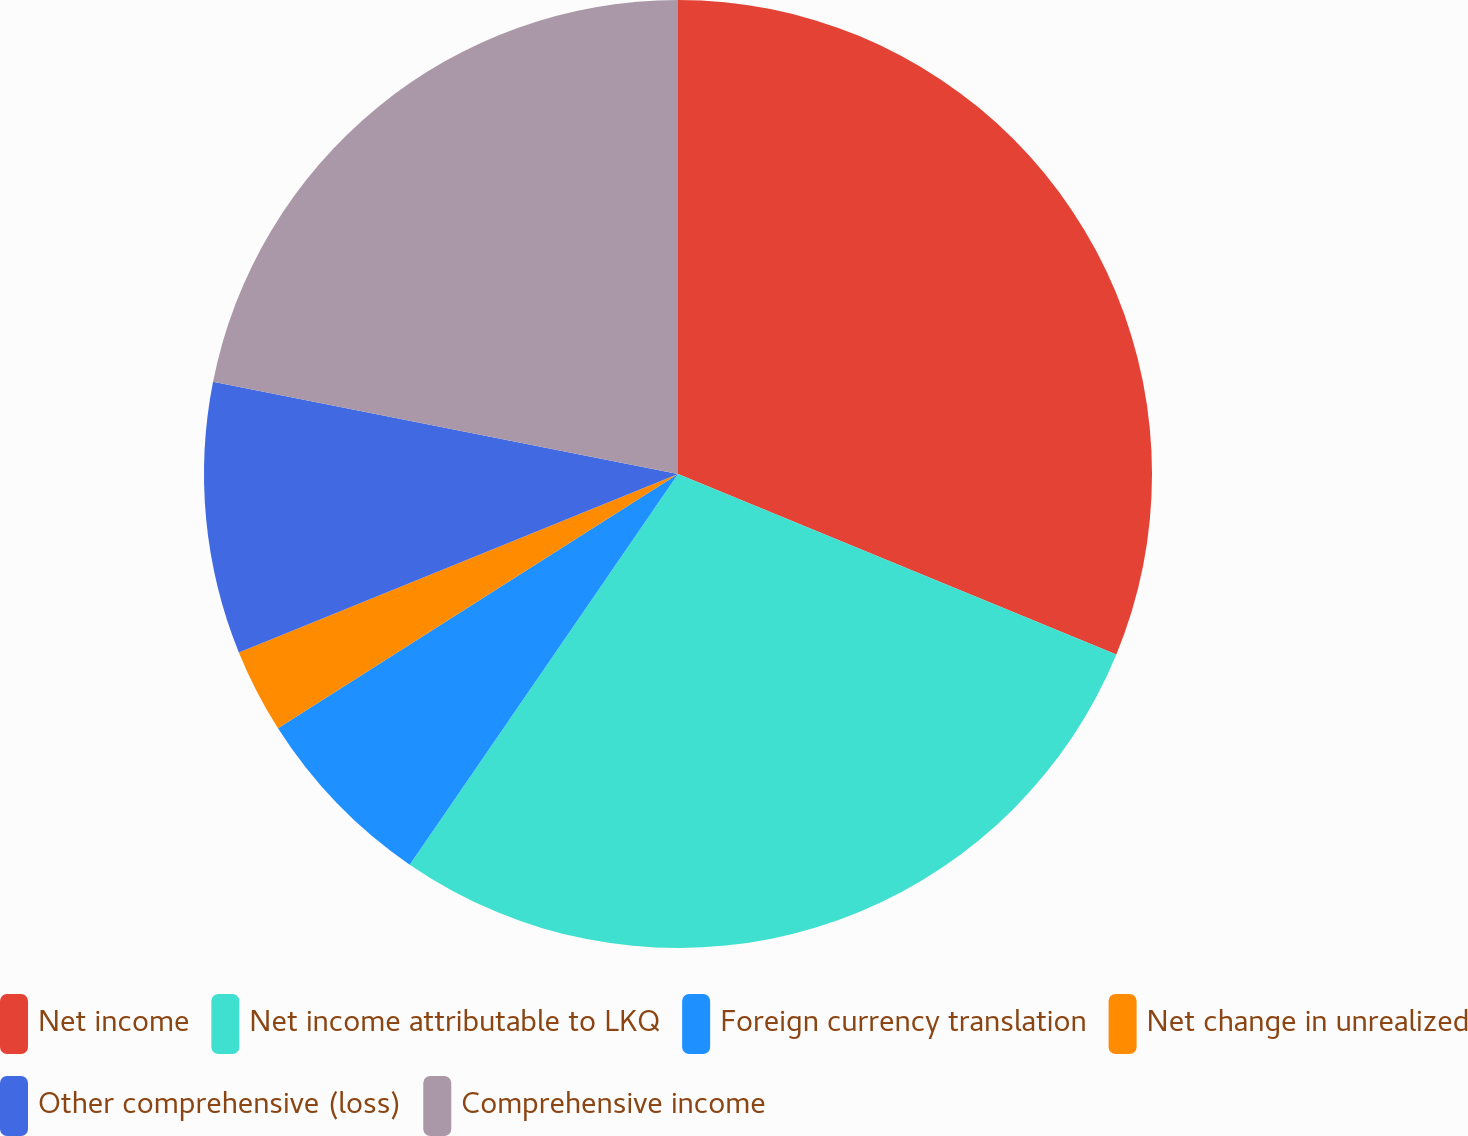Convert chart to OTSL. <chart><loc_0><loc_0><loc_500><loc_500><pie_chart><fcel>Net income<fcel>Net income attributable to LKQ<fcel>Foreign currency translation<fcel>Net change in unrealized<fcel>Other comprehensive (loss)<fcel>Comprehensive income<nl><fcel>31.21%<fcel>28.36%<fcel>6.41%<fcel>2.87%<fcel>9.26%<fcel>21.88%<nl></chart> 